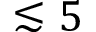<formula> <loc_0><loc_0><loc_500><loc_500>\lesssim 5</formula> 